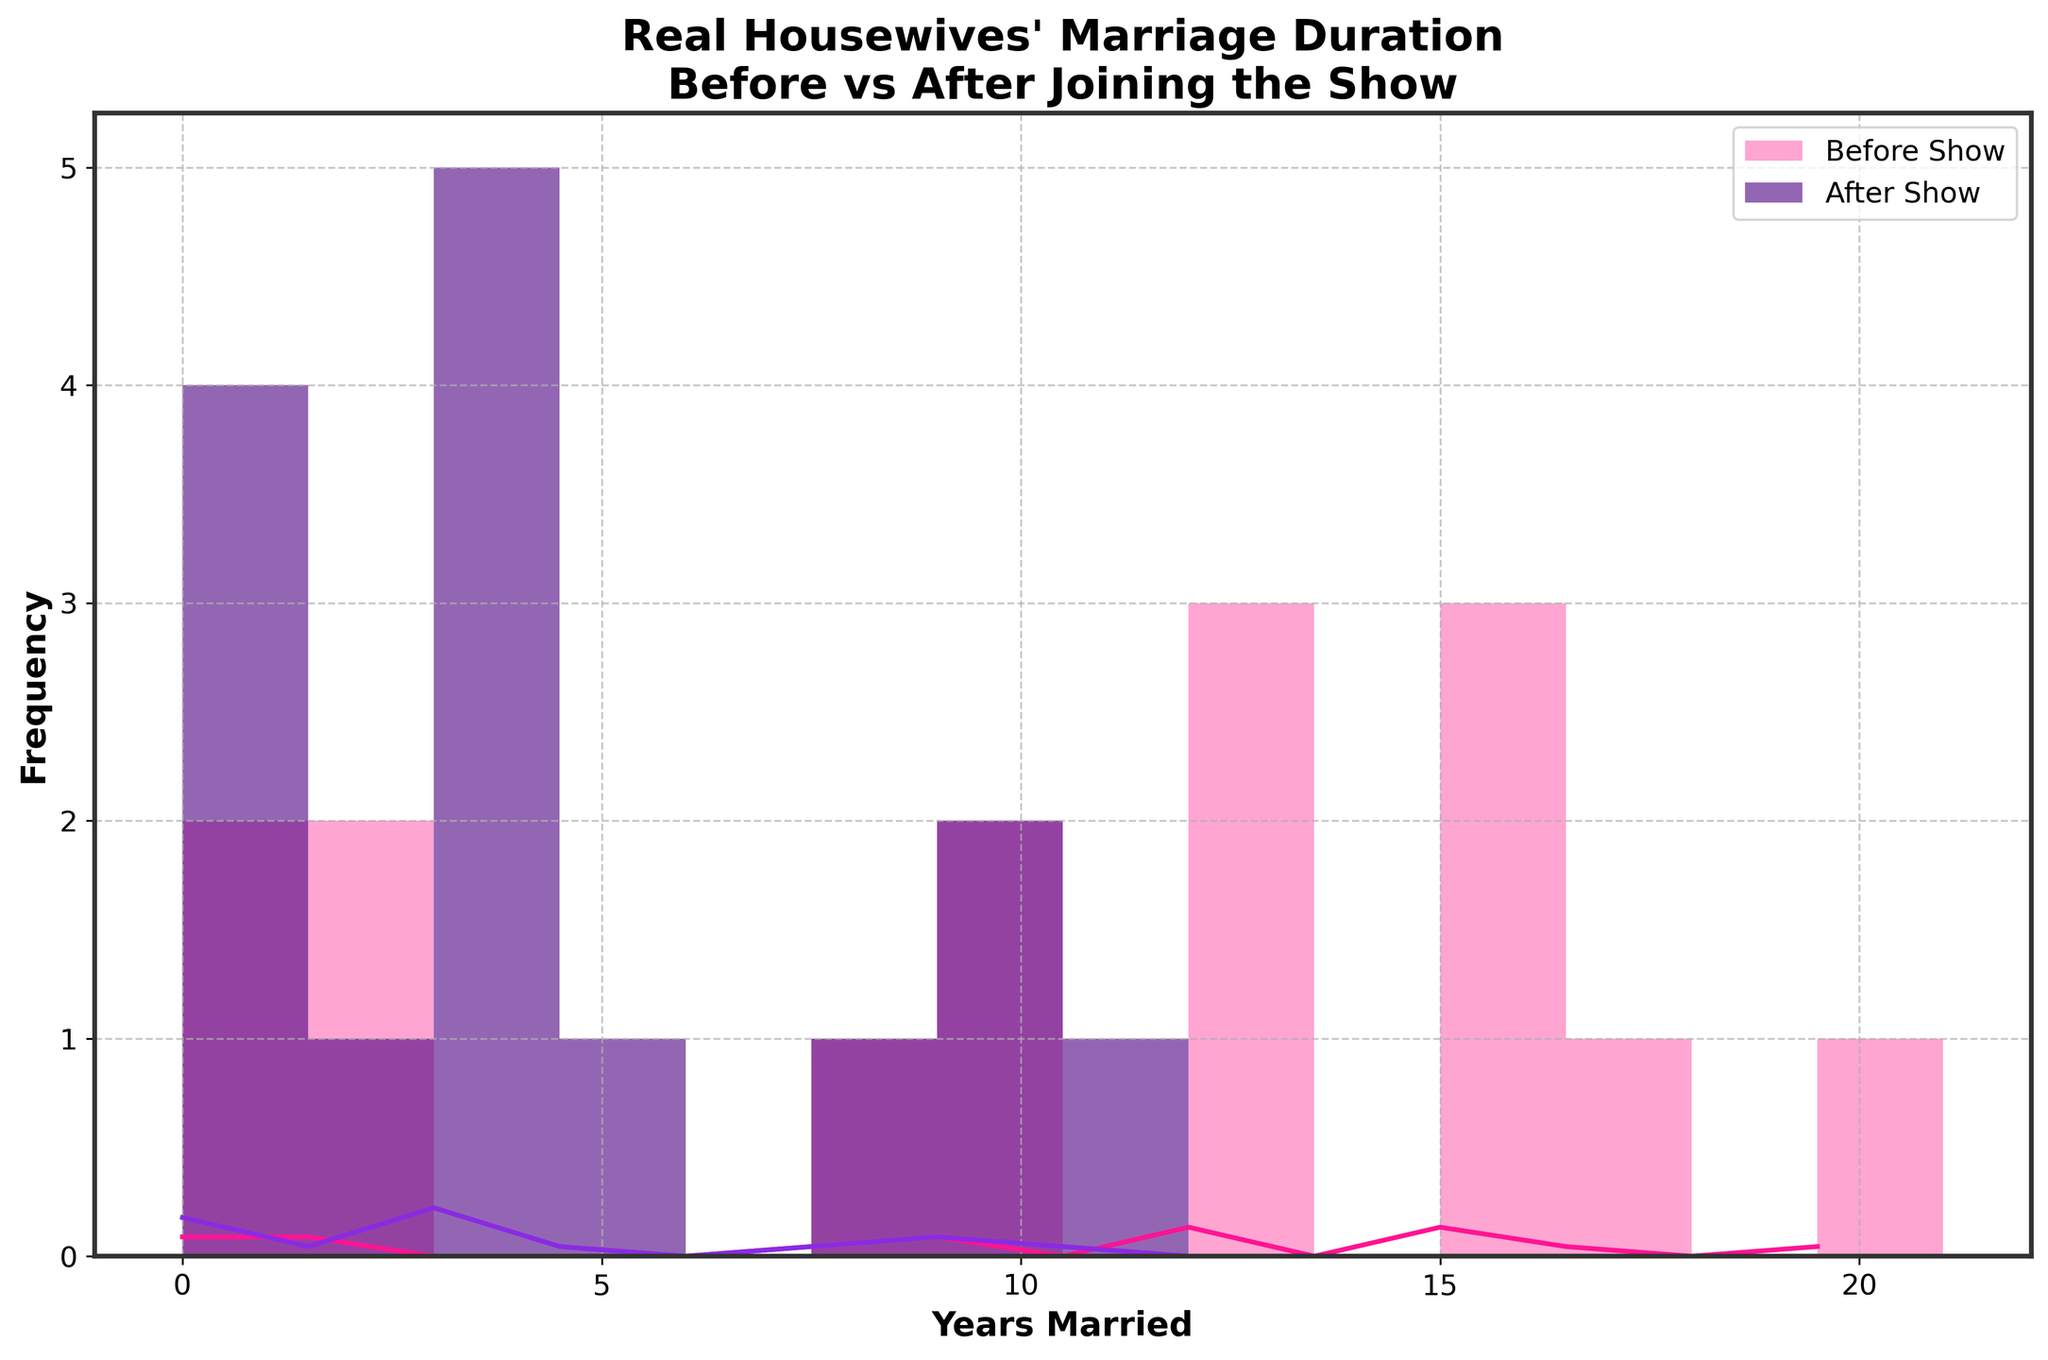What is the title of the plot? The title of the plot is written at the top center of the figure. It provides a brief description of what the plot is about. In this case, it describes the marriage durations for the Real Housewives cast members before and after joining the show.
Answer: "Real Housewives' Marriage Duration Before vs After Joining the Show" What are the x-axis and y-axis labels? The x-axis label indicates what is being measured on the horizontal axis, and the y-axis label indicates the frequency on the vertical axis. The x-axis is labeled "Years Married" and the y-axis is labeled "Frequency."
Answer: "Years Married" and "Frequency" Which color represents marriages before joining the show? The plot uses different colors to represent different groups. In this plot, the histogram for marriages before joining the show is colored pink, matching the label in the legend.
Answer: Pink Which group shows a taller peak in the KDE curve, before or after joining the show? The KDE curve represents the density of the distribution. By visually comparing the two KDE curves, we see that the KDE curve for marriages before joining the show (pink) has a taller peak.
Answer: Before joining the show How many bins are used in the histogram? The number of bins can be determined by counting the vertical bars in the histogram. In this plot, by counting the bars, we can see that there are 14 bins.
Answer: 14 What is the range of years married shown on the x-axis? The x-axis spans from the lowest value to the highest value indicated on the plot. From the axis ticks, the range is from 0 to 30 years.
Answer: 0 to 30 years How many years did Lisa Vanderpump stay married after joining the show? We need to look at the data provided: Lisa Vanderpump stayed married for 11 years after joining the show.
Answer: 11 Between 5 and 15 years married, which group has a higher frequency, before or after joining the show? By visually examining the bars within the 5 to 15 years range, we can see which color dominates in that range. For the 5-15 years range, the pink bars (before joining the show) have a higher frequency.
Answer: Before joining the show What's the difference between the tallest KDE peaks for before and after joining the show? The KDE curves show the density of the distribution. The tallest peak for before joining (pink) is around 0.25, and for after joining (purple) is around 0.18. The difference is 0.25 - 0.18.
Answer: 0.07 Does the plot show more significant drops in frequency for marriages before or after joining the show? By observing the shape and height of the histogram bars, we can see if there are more significant drops. The after joining group (purple bars) shows more significant drops in frequency.
Answer: After joining the show 